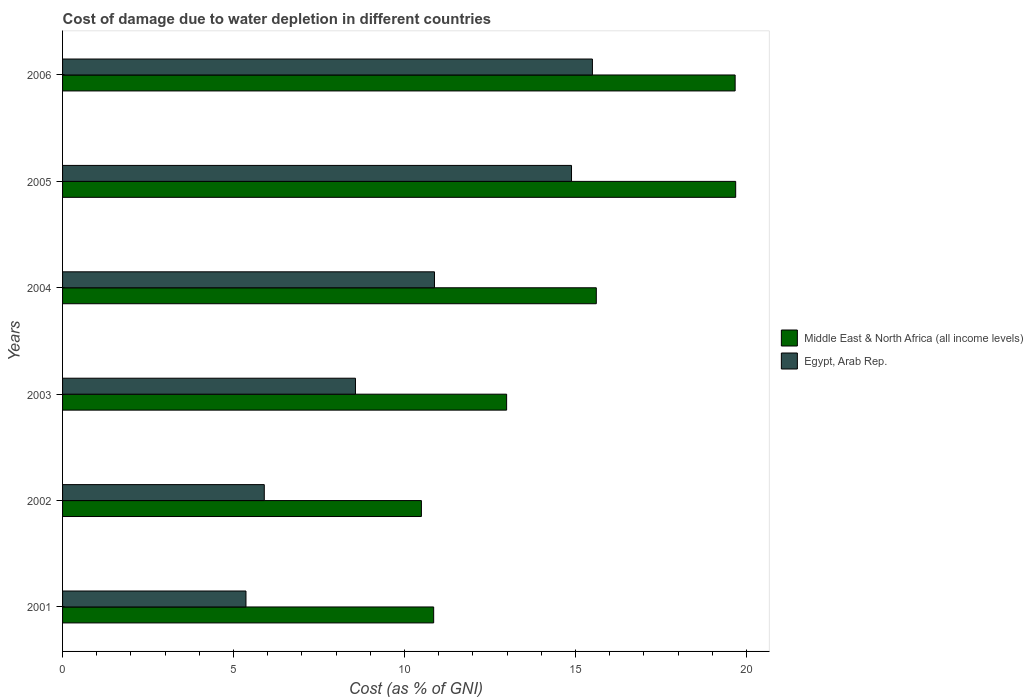How many different coloured bars are there?
Provide a succinct answer. 2. How many groups of bars are there?
Your answer should be very brief. 6. Are the number of bars on each tick of the Y-axis equal?
Offer a terse response. Yes. How many bars are there on the 3rd tick from the top?
Offer a very short reply. 2. What is the label of the 2nd group of bars from the top?
Your answer should be very brief. 2005. What is the cost of damage caused due to water depletion in Egypt, Arab Rep. in 2004?
Your answer should be compact. 10.87. Across all years, what is the maximum cost of damage caused due to water depletion in Egypt, Arab Rep.?
Offer a very short reply. 15.49. Across all years, what is the minimum cost of damage caused due to water depletion in Middle East & North Africa (all income levels)?
Provide a short and direct response. 10.49. In which year was the cost of damage caused due to water depletion in Middle East & North Africa (all income levels) maximum?
Ensure brevity in your answer.  2005. What is the total cost of damage caused due to water depletion in Middle East & North Africa (all income levels) in the graph?
Offer a terse response. 89.28. What is the difference between the cost of damage caused due to water depletion in Middle East & North Africa (all income levels) in 2002 and that in 2004?
Offer a terse response. -5.11. What is the difference between the cost of damage caused due to water depletion in Middle East & North Africa (all income levels) in 2004 and the cost of damage caused due to water depletion in Egypt, Arab Rep. in 2003?
Provide a short and direct response. 7.04. What is the average cost of damage caused due to water depletion in Middle East & North Africa (all income levels) per year?
Offer a terse response. 14.88. In the year 2001, what is the difference between the cost of damage caused due to water depletion in Egypt, Arab Rep. and cost of damage caused due to water depletion in Middle East & North Africa (all income levels)?
Provide a short and direct response. -5.49. In how many years, is the cost of damage caused due to water depletion in Middle East & North Africa (all income levels) greater than 4 %?
Offer a very short reply. 6. What is the ratio of the cost of damage caused due to water depletion in Middle East & North Africa (all income levels) in 2002 to that in 2003?
Your answer should be compact. 0.81. What is the difference between the highest and the second highest cost of damage caused due to water depletion in Egypt, Arab Rep.?
Make the answer very short. 0.61. What is the difference between the highest and the lowest cost of damage caused due to water depletion in Egypt, Arab Rep.?
Provide a short and direct response. 10.13. In how many years, is the cost of damage caused due to water depletion in Egypt, Arab Rep. greater than the average cost of damage caused due to water depletion in Egypt, Arab Rep. taken over all years?
Keep it short and to the point. 3. Is the sum of the cost of damage caused due to water depletion in Middle East & North Africa (all income levels) in 2001 and 2002 greater than the maximum cost of damage caused due to water depletion in Egypt, Arab Rep. across all years?
Offer a terse response. Yes. What does the 2nd bar from the top in 2006 represents?
Ensure brevity in your answer.  Middle East & North Africa (all income levels). What does the 1st bar from the bottom in 2006 represents?
Your answer should be very brief. Middle East & North Africa (all income levels). How many bars are there?
Provide a short and direct response. 12. Are all the bars in the graph horizontal?
Ensure brevity in your answer.  Yes. What is the difference between two consecutive major ticks on the X-axis?
Your answer should be compact. 5. Does the graph contain any zero values?
Offer a very short reply. No. How many legend labels are there?
Your answer should be very brief. 2. How are the legend labels stacked?
Your response must be concise. Vertical. What is the title of the graph?
Your response must be concise. Cost of damage due to water depletion in different countries. Does "Argentina" appear as one of the legend labels in the graph?
Make the answer very short. No. What is the label or title of the X-axis?
Your answer should be compact. Cost (as % of GNI). What is the label or title of the Y-axis?
Your answer should be compact. Years. What is the Cost (as % of GNI) of Middle East & North Africa (all income levels) in 2001?
Keep it short and to the point. 10.85. What is the Cost (as % of GNI) in Egypt, Arab Rep. in 2001?
Give a very brief answer. 5.36. What is the Cost (as % of GNI) in Middle East & North Africa (all income levels) in 2002?
Your response must be concise. 10.49. What is the Cost (as % of GNI) in Egypt, Arab Rep. in 2002?
Ensure brevity in your answer.  5.9. What is the Cost (as % of GNI) of Middle East & North Africa (all income levels) in 2003?
Make the answer very short. 12.98. What is the Cost (as % of GNI) of Egypt, Arab Rep. in 2003?
Your response must be concise. 8.56. What is the Cost (as % of GNI) in Middle East & North Africa (all income levels) in 2004?
Make the answer very short. 15.61. What is the Cost (as % of GNI) of Egypt, Arab Rep. in 2004?
Provide a short and direct response. 10.87. What is the Cost (as % of GNI) in Middle East & North Africa (all income levels) in 2005?
Your answer should be very brief. 19.68. What is the Cost (as % of GNI) in Egypt, Arab Rep. in 2005?
Your answer should be very brief. 14.88. What is the Cost (as % of GNI) of Middle East & North Africa (all income levels) in 2006?
Offer a terse response. 19.67. What is the Cost (as % of GNI) of Egypt, Arab Rep. in 2006?
Ensure brevity in your answer.  15.49. Across all years, what is the maximum Cost (as % of GNI) of Middle East & North Africa (all income levels)?
Give a very brief answer. 19.68. Across all years, what is the maximum Cost (as % of GNI) of Egypt, Arab Rep.?
Your response must be concise. 15.49. Across all years, what is the minimum Cost (as % of GNI) in Middle East & North Africa (all income levels)?
Your answer should be compact. 10.49. Across all years, what is the minimum Cost (as % of GNI) of Egypt, Arab Rep.?
Provide a short and direct response. 5.36. What is the total Cost (as % of GNI) of Middle East & North Africa (all income levels) in the graph?
Your answer should be very brief. 89.28. What is the total Cost (as % of GNI) in Egypt, Arab Rep. in the graph?
Your answer should be very brief. 61.07. What is the difference between the Cost (as % of GNI) of Middle East & North Africa (all income levels) in 2001 and that in 2002?
Ensure brevity in your answer.  0.36. What is the difference between the Cost (as % of GNI) of Egypt, Arab Rep. in 2001 and that in 2002?
Ensure brevity in your answer.  -0.54. What is the difference between the Cost (as % of GNI) of Middle East & North Africa (all income levels) in 2001 and that in 2003?
Keep it short and to the point. -2.13. What is the difference between the Cost (as % of GNI) of Egypt, Arab Rep. in 2001 and that in 2003?
Provide a succinct answer. -3.2. What is the difference between the Cost (as % of GNI) in Middle East & North Africa (all income levels) in 2001 and that in 2004?
Your answer should be compact. -4.76. What is the difference between the Cost (as % of GNI) in Egypt, Arab Rep. in 2001 and that in 2004?
Give a very brief answer. -5.51. What is the difference between the Cost (as % of GNI) of Middle East & North Africa (all income levels) in 2001 and that in 2005?
Provide a succinct answer. -8.83. What is the difference between the Cost (as % of GNI) in Egypt, Arab Rep. in 2001 and that in 2005?
Make the answer very short. -9.52. What is the difference between the Cost (as % of GNI) of Middle East & North Africa (all income levels) in 2001 and that in 2006?
Your response must be concise. -8.81. What is the difference between the Cost (as % of GNI) in Egypt, Arab Rep. in 2001 and that in 2006?
Keep it short and to the point. -10.13. What is the difference between the Cost (as % of GNI) of Middle East & North Africa (all income levels) in 2002 and that in 2003?
Provide a succinct answer. -2.49. What is the difference between the Cost (as % of GNI) in Egypt, Arab Rep. in 2002 and that in 2003?
Provide a succinct answer. -2.67. What is the difference between the Cost (as % of GNI) in Middle East & North Africa (all income levels) in 2002 and that in 2004?
Offer a very short reply. -5.11. What is the difference between the Cost (as % of GNI) of Egypt, Arab Rep. in 2002 and that in 2004?
Offer a terse response. -4.98. What is the difference between the Cost (as % of GNI) in Middle East & North Africa (all income levels) in 2002 and that in 2005?
Your answer should be very brief. -9.19. What is the difference between the Cost (as % of GNI) in Egypt, Arab Rep. in 2002 and that in 2005?
Keep it short and to the point. -8.98. What is the difference between the Cost (as % of GNI) in Middle East & North Africa (all income levels) in 2002 and that in 2006?
Your answer should be compact. -9.17. What is the difference between the Cost (as % of GNI) of Egypt, Arab Rep. in 2002 and that in 2006?
Your answer should be very brief. -9.59. What is the difference between the Cost (as % of GNI) of Middle East & North Africa (all income levels) in 2003 and that in 2004?
Make the answer very short. -2.62. What is the difference between the Cost (as % of GNI) of Egypt, Arab Rep. in 2003 and that in 2004?
Your answer should be compact. -2.31. What is the difference between the Cost (as % of GNI) of Middle East & North Africa (all income levels) in 2003 and that in 2005?
Your response must be concise. -6.7. What is the difference between the Cost (as % of GNI) in Egypt, Arab Rep. in 2003 and that in 2005?
Offer a very short reply. -6.32. What is the difference between the Cost (as % of GNI) of Middle East & North Africa (all income levels) in 2003 and that in 2006?
Your answer should be very brief. -6.68. What is the difference between the Cost (as % of GNI) of Egypt, Arab Rep. in 2003 and that in 2006?
Offer a terse response. -6.93. What is the difference between the Cost (as % of GNI) in Middle East & North Africa (all income levels) in 2004 and that in 2005?
Your answer should be compact. -4.08. What is the difference between the Cost (as % of GNI) of Egypt, Arab Rep. in 2004 and that in 2005?
Keep it short and to the point. -4.01. What is the difference between the Cost (as % of GNI) of Middle East & North Africa (all income levels) in 2004 and that in 2006?
Keep it short and to the point. -4.06. What is the difference between the Cost (as % of GNI) of Egypt, Arab Rep. in 2004 and that in 2006?
Your answer should be compact. -4.62. What is the difference between the Cost (as % of GNI) of Middle East & North Africa (all income levels) in 2005 and that in 2006?
Keep it short and to the point. 0.02. What is the difference between the Cost (as % of GNI) of Egypt, Arab Rep. in 2005 and that in 2006?
Give a very brief answer. -0.61. What is the difference between the Cost (as % of GNI) of Middle East & North Africa (all income levels) in 2001 and the Cost (as % of GNI) of Egypt, Arab Rep. in 2002?
Your answer should be very brief. 4.95. What is the difference between the Cost (as % of GNI) in Middle East & North Africa (all income levels) in 2001 and the Cost (as % of GNI) in Egypt, Arab Rep. in 2003?
Provide a succinct answer. 2.29. What is the difference between the Cost (as % of GNI) in Middle East & North Africa (all income levels) in 2001 and the Cost (as % of GNI) in Egypt, Arab Rep. in 2004?
Offer a terse response. -0.02. What is the difference between the Cost (as % of GNI) of Middle East & North Africa (all income levels) in 2001 and the Cost (as % of GNI) of Egypt, Arab Rep. in 2005?
Ensure brevity in your answer.  -4.03. What is the difference between the Cost (as % of GNI) in Middle East & North Africa (all income levels) in 2001 and the Cost (as % of GNI) in Egypt, Arab Rep. in 2006?
Offer a very short reply. -4.64. What is the difference between the Cost (as % of GNI) of Middle East & North Africa (all income levels) in 2002 and the Cost (as % of GNI) of Egypt, Arab Rep. in 2003?
Give a very brief answer. 1.93. What is the difference between the Cost (as % of GNI) in Middle East & North Africa (all income levels) in 2002 and the Cost (as % of GNI) in Egypt, Arab Rep. in 2004?
Make the answer very short. -0.38. What is the difference between the Cost (as % of GNI) in Middle East & North Africa (all income levels) in 2002 and the Cost (as % of GNI) in Egypt, Arab Rep. in 2005?
Make the answer very short. -4.39. What is the difference between the Cost (as % of GNI) in Middle East & North Africa (all income levels) in 2002 and the Cost (as % of GNI) in Egypt, Arab Rep. in 2006?
Offer a very short reply. -5. What is the difference between the Cost (as % of GNI) of Middle East & North Africa (all income levels) in 2003 and the Cost (as % of GNI) of Egypt, Arab Rep. in 2004?
Give a very brief answer. 2.11. What is the difference between the Cost (as % of GNI) in Middle East & North Africa (all income levels) in 2003 and the Cost (as % of GNI) in Egypt, Arab Rep. in 2005?
Keep it short and to the point. -1.9. What is the difference between the Cost (as % of GNI) of Middle East & North Africa (all income levels) in 2003 and the Cost (as % of GNI) of Egypt, Arab Rep. in 2006?
Offer a terse response. -2.51. What is the difference between the Cost (as % of GNI) in Middle East & North Africa (all income levels) in 2004 and the Cost (as % of GNI) in Egypt, Arab Rep. in 2005?
Keep it short and to the point. 0.73. What is the difference between the Cost (as % of GNI) of Middle East & North Africa (all income levels) in 2004 and the Cost (as % of GNI) of Egypt, Arab Rep. in 2006?
Provide a succinct answer. 0.11. What is the difference between the Cost (as % of GNI) in Middle East & North Africa (all income levels) in 2005 and the Cost (as % of GNI) in Egypt, Arab Rep. in 2006?
Keep it short and to the point. 4.19. What is the average Cost (as % of GNI) in Middle East & North Africa (all income levels) per year?
Keep it short and to the point. 14.88. What is the average Cost (as % of GNI) of Egypt, Arab Rep. per year?
Your answer should be compact. 10.18. In the year 2001, what is the difference between the Cost (as % of GNI) of Middle East & North Africa (all income levels) and Cost (as % of GNI) of Egypt, Arab Rep.?
Provide a short and direct response. 5.49. In the year 2002, what is the difference between the Cost (as % of GNI) in Middle East & North Africa (all income levels) and Cost (as % of GNI) in Egypt, Arab Rep.?
Your response must be concise. 4.59. In the year 2003, what is the difference between the Cost (as % of GNI) of Middle East & North Africa (all income levels) and Cost (as % of GNI) of Egypt, Arab Rep.?
Your answer should be compact. 4.42. In the year 2004, what is the difference between the Cost (as % of GNI) of Middle East & North Africa (all income levels) and Cost (as % of GNI) of Egypt, Arab Rep.?
Ensure brevity in your answer.  4.73. In the year 2005, what is the difference between the Cost (as % of GNI) of Middle East & North Africa (all income levels) and Cost (as % of GNI) of Egypt, Arab Rep.?
Keep it short and to the point. 4.8. In the year 2006, what is the difference between the Cost (as % of GNI) in Middle East & North Africa (all income levels) and Cost (as % of GNI) in Egypt, Arab Rep.?
Your answer should be compact. 4.17. What is the ratio of the Cost (as % of GNI) in Middle East & North Africa (all income levels) in 2001 to that in 2002?
Provide a succinct answer. 1.03. What is the ratio of the Cost (as % of GNI) in Egypt, Arab Rep. in 2001 to that in 2002?
Provide a short and direct response. 0.91. What is the ratio of the Cost (as % of GNI) in Middle East & North Africa (all income levels) in 2001 to that in 2003?
Provide a succinct answer. 0.84. What is the ratio of the Cost (as % of GNI) in Egypt, Arab Rep. in 2001 to that in 2003?
Keep it short and to the point. 0.63. What is the ratio of the Cost (as % of GNI) of Middle East & North Africa (all income levels) in 2001 to that in 2004?
Your answer should be compact. 0.7. What is the ratio of the Cost (as % of GNI) in Egypt, Arab Rep. in 2001 to that in 2004?
Your response must be concise. 0.49. What is the ratio of the Cost (as % of GNI) in Middle East & North Africa (all income levels) in 2001 to that in 2005?
Your answer should be very brief. 0.55. What is the ratio of the Cost (as % of GNI) in Egypt, Arab Rep. in 2001 to that in 2005?
Offer a very short reply. 0.36. What is the ratio of the Cost (as % of GNI) in Middle East & North Africa (all income levels) in 2001 to that in 2006?
Offer a terse response. 0.55. What is the ratio of the Cost (as % of GNI) of Egypt, Arab Rep. in 2001 to that in 2006?
Make the answer very short. 0.35. What is the ratio of the Cost (as % of GNI) of Middle East & North Africa (all income levels) in 2002 to that in 2003?
Make the answer very short. 0.81. What is the ratio of the Cost (as % of GNI) in Egypt, Arab Rep. in 2002 to that in 2003?
Keep it short and to the point. 0.69. What is the ratio of the Cost (as % of GNI) in Middle East & North Africa (all income levels) in 2002 to that in 2004?
Your answer should be compact. 0.67. What is the ratio of the Cost (as % of GNI) in Egypt, Arab Rep. in 2002 to that in 2004?
Your answer should be compact. 0.54. What is the ratio of the Cost (as % of GNI) in Middle East & North Africa (all income levels) in 2002 to that in 2005?
Offer a terse response. 0.53. What is the ratio of the Cost (as % of GNI) in Egypt, Arab Rep. in 2002 to that in 2005?
Ensure brevity in your answer.  0.4. What is the ratio of the Cost (as % of GNI) in Middle East & North Africa (all income levels) in 2002 to that in 2006?
Your response must be concise. 0.53. What is the ratio of the Cost (as % of GNI) of Egypt, Arab Rep. in 2002 to that in 2006?
Provide a short and direct response. 0.38. What is the ratio of the Cost (as % of GNI) in Middle East & North Africa (all income levels) in 2003 to that in 2004?
Ensure brevity in your answer.  0.83. What is the ratio of the Cost (as % of GNI) of Egypt, Arab Rep. in 2003 to that in 2004?
Your answer should be very brief. 0.79. What is the ratio of the Cost (as % of GNI) of Middle East & North Africa (all income levels) in 2003 to that in 2005?
Your response must be concise. 0.66. What is the ratio of the Cost (as % of GNI) in Egypt, Arab Rep. in 2003 to that in 2005?
Your answer should be very brief. 0.58. What is the ratio of the Cost (as % of GNI) in Middle East & North Africa (all income levels) in 2003 to that in 2006?
Ensure brevity in your answer.  0.66. What is the ratio of the Cost (as % of GNI) in Egypt, Arab Rep. in 2003 to that in 2006?
Offer a very short reply. 0.55. What is the ratio of the Cost (as % of GNI) of Middle East & North Africa (all income levels) in 2004 to that in 2005?
Give a very brief answer. 0.79. What is the ratio of the Cost (as % of GNI) of Egypt, Arab Rep. in 2004 to that in 2005?
Your answer should be very brief. 0.73. What is the ratio of the Cost (as % of GNI) in Middle East & North Africa (all income levels) in 2004 to that in 2006?
Provide a short and direct response. 0.79. What is the ratio of the Cost (as % of GNI) in Egypt, Arab Rep. in 2004 to that in 2006?
Ensure brevity in your answer.  0.7. What is the ratio of the Cost (as % of GNI) in Middle East & North Africa (all income levels) in 2005 to that in 2006?
Your answer should be compact. 1. What is the ratio of the Cost (as % of GNI) in Egypt, Arab Rep. in 2005 to that in 2006?
Your answer should be compact. 0.96. What is the difference between the highest and the second highest Cost (as % of GNI) in Middle East & North Africa (all income levels)?
Make the answer very short. 0.02. What is the difference between the highest and the second highest Cost (as % of GNI) of Egypt, Arab Rep.?
Offer a terse response. 0.61. What is the difference between the highest and the lowest Cost (as % of GNI) in Middle East & North Africa (all income levels)?
Your answer should be very brief. 9.19. What is the difference between the highest and the lowest Cost (as % of GNI) of Egypt, Arab Rep.?
Offer a very short reply. 10.13. 